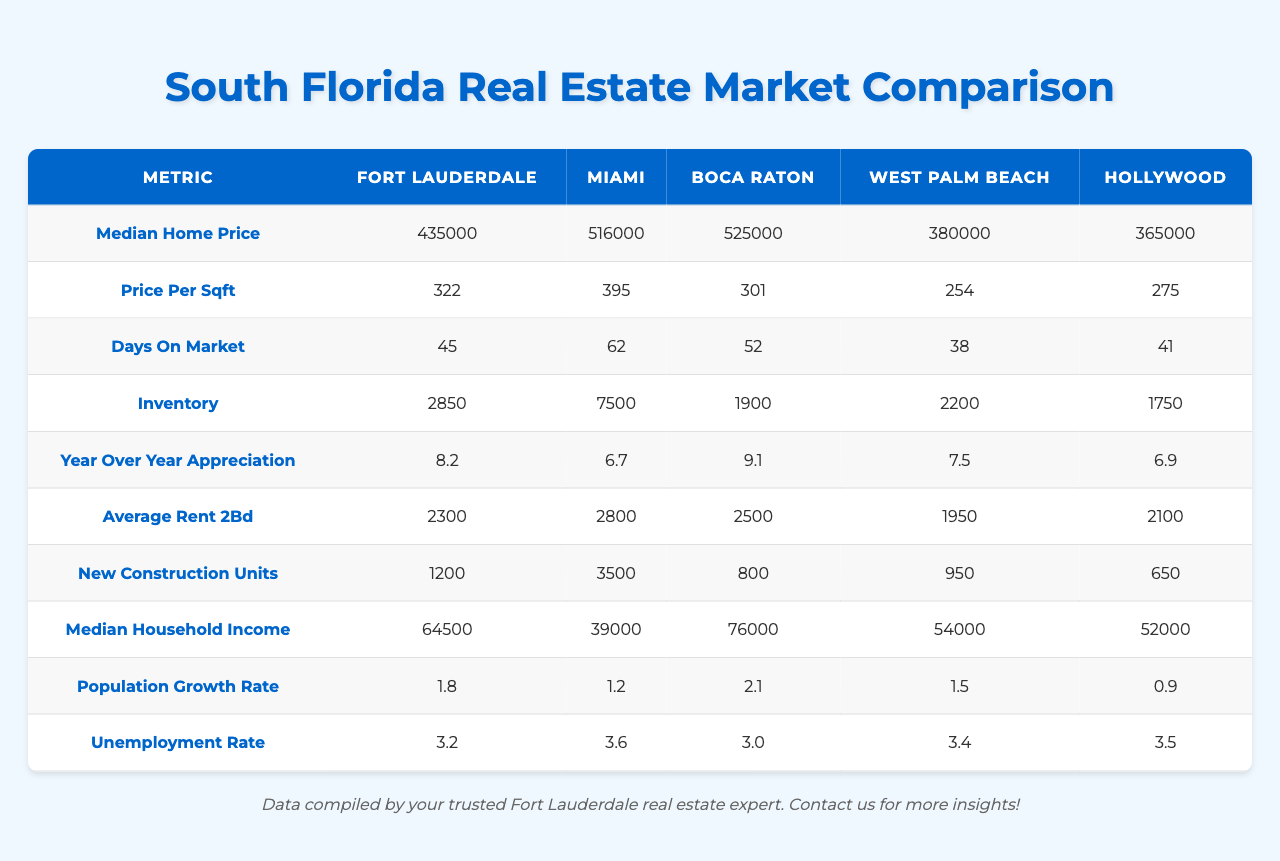What city has the highest median home price? The median home prices for the cities are: Fort Lauderdale - $435,000, Miami - $516,000, Boca Raton - $525,000, West Palm Beach - $380,000, Hollywood - $365,000. Boca Raton has the highest median home price at $525,000.
Answer: Boca Raton What is the price per square foot in Miami? The table shows that the price per square foot in Miami is $395.
Answer: $395 Which city has the shortest days on market for homes? The days on market for the cities are: Fort Lauderdale - 45, Miami - 62, Boca Raton - 52, West Palm Beach - 38, Hollywood - 41. West Palm Beach has the shortest days on market at 38 days.
Answer: West Palm Beach What is the average rent for a 2-bedroom apartment across the listed cities? The average rent for a 2-bedroom apartment is calculated by adding the rents: (2300 + 2800 + 2500 + 1950 + 2100) = 11650, then dividing by 5, which results in an average rent of 11650 / 5 = $2330.
Answer: $2330 Is the year-over-year appreciation higher in Fort Lauderdale or Hollywood? The year-over-year appreciation in Fort Lauderdale is 8.2% and in Hollywood is 6.9%. Since 8.2% is greater than 6.9%, Fort Lauderdale has a higher appreciation.
Answer: Yes What is the difference in inventory between Miami and Boca Raton? The inventory for Miami is 7500, and for Boca Raton, it is 1900. The difference can be calculated as 7500 - 1900 = 5600.
Answer: 5600 Which city has the lowest median household income? The median household incomes for the cities are: Fort Lauderdale - $64,500, Miami - $39,000, Boca Raton - $76,000, West Palm Beach - $54,000, and Hollywood - $52,000. Miami has the lowest median household income at $39,000.
Answer: Miami What is the population growth rate for Boca Raton? The population growth rate for Boca Raton is listed in the table as 2.1%.
Answer: 2.1% Which city has the highest unemployment rate and what is it? The unemployment rates are: Fort Lauderdale - 3.2%, Miami - 3.6%, Boca Raton - 3.0%, West Palm Beach - 3.4%, Hollywood - 3.5%. Miami has the highest unemployment rate at 3.6%.
Answer: Miami, 3.6% If the inventory in Hollywood is 1750, what is the total inventory for all cities? The total inventory is found by summing the inventory values: 2850 + 7500 + 1900 + 2200 + 1750 = 16200.
Answer: 16200 